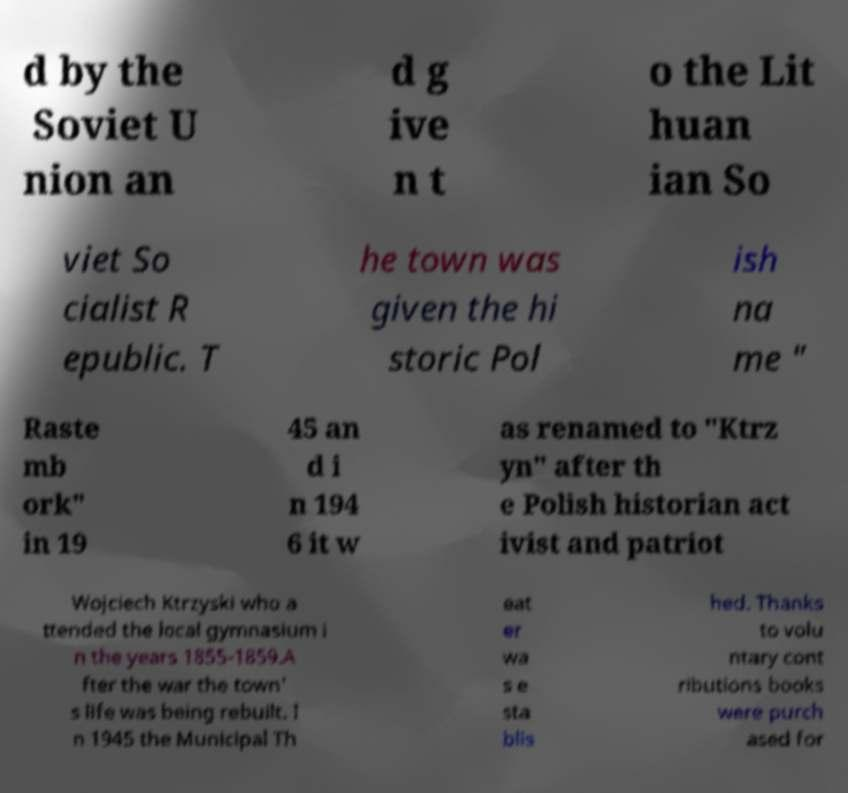Could you assist in decoding the text presented in this image and type it out clearly? d by the Soviet U nion an d g ive n t o the Lit huan ian So viet So cialist R epublic. T he town was given the hi storic Pol ish na me " Raste mb ork" in 19 45 an d i n 194 6 it w as renamed to "Ktrz yn" after th e Polish historian act ivist and patriot Wojciech Ktrzyski who a ttended the local gymnasium i n the years 1855-1859.A fter the war the town' s life was being rebuilt. I n 1945 the Municipal Th eat er wa s e sta blis hed. Thanks to volu ntary cont ributions books were purch ased for 